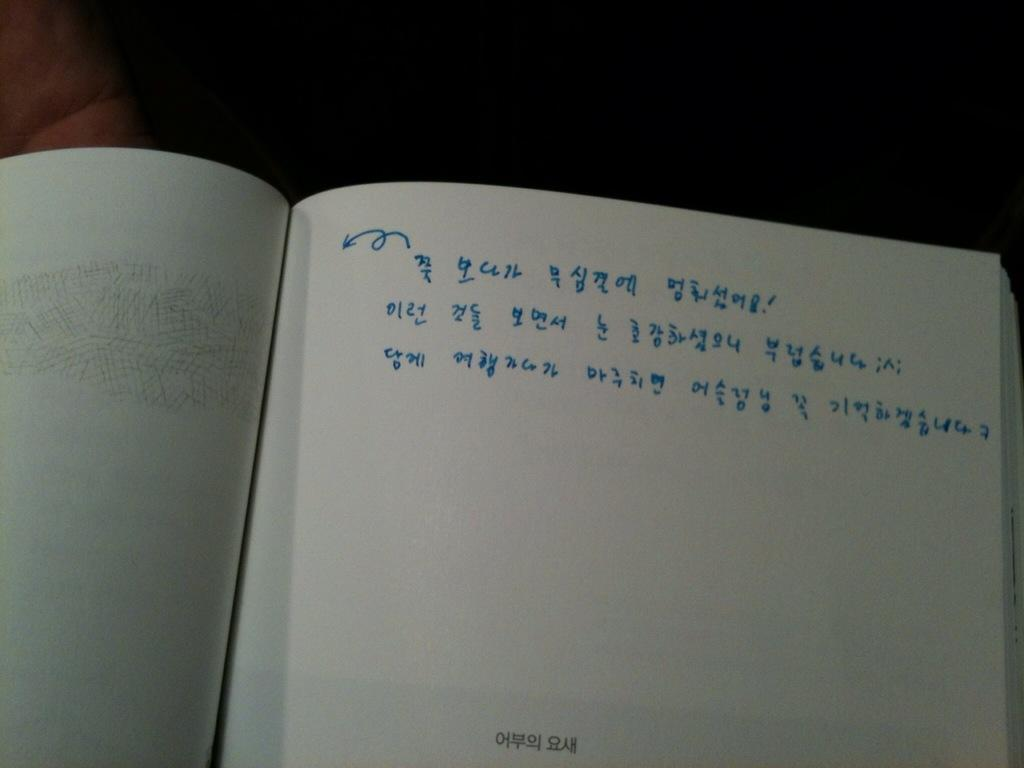<image>
Offer a succinct explanation of the picture presented. A notebook page has Korean handwriting in blue on it. 